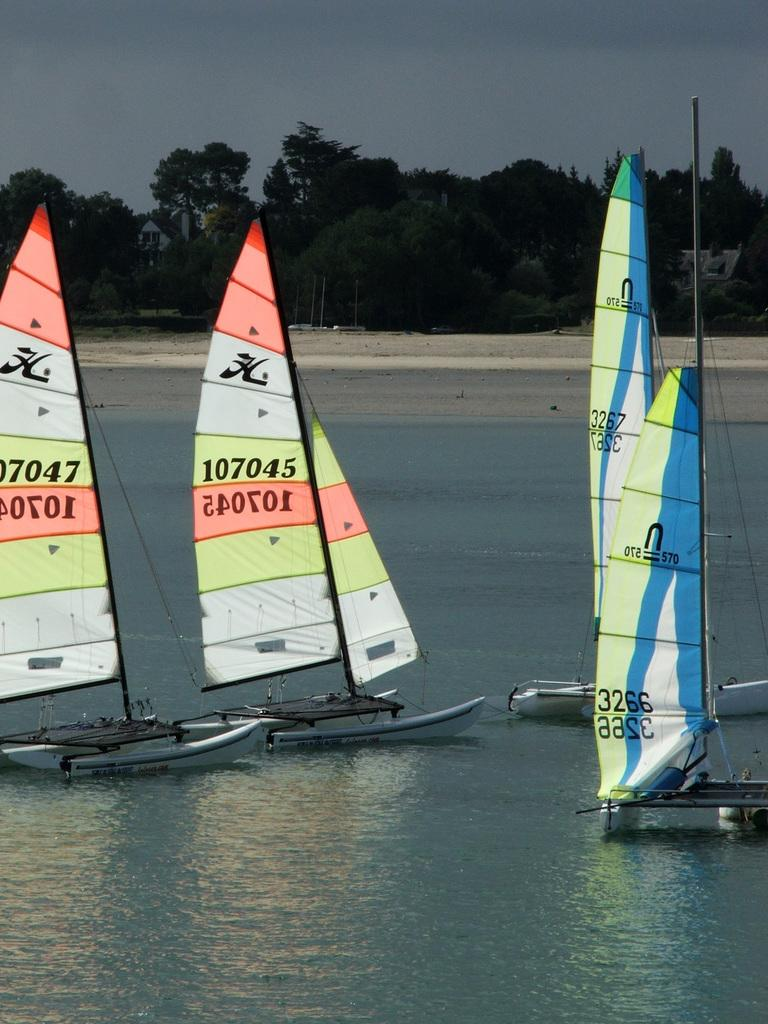Provide a one-sentence caption for the provided image. Sailboats with number 107045 and 107047 are in the water. 